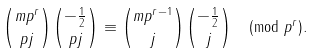<formula> <loc_0><loc_0><loc_500><loc_500>\binom { m p ^ { r } } { p j } \binom { - \frac { 1 } { 2 } } { p j } \equiv \binom { m p ^ { r - 1 } } { j } \binom { - \frac { 1 } { 2 } } { j } \pmod { p ^ { r } } .</formula> 